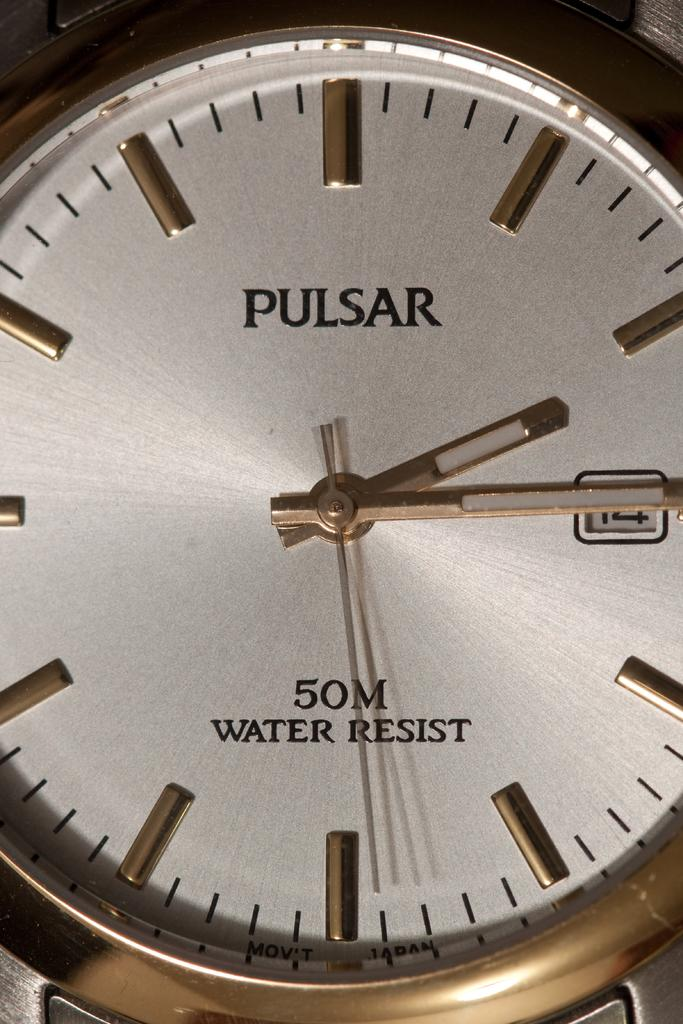<image>
Share a concise interpretation of the image provided. A Pulsar watch says that it is water resistant for 50 meters. 